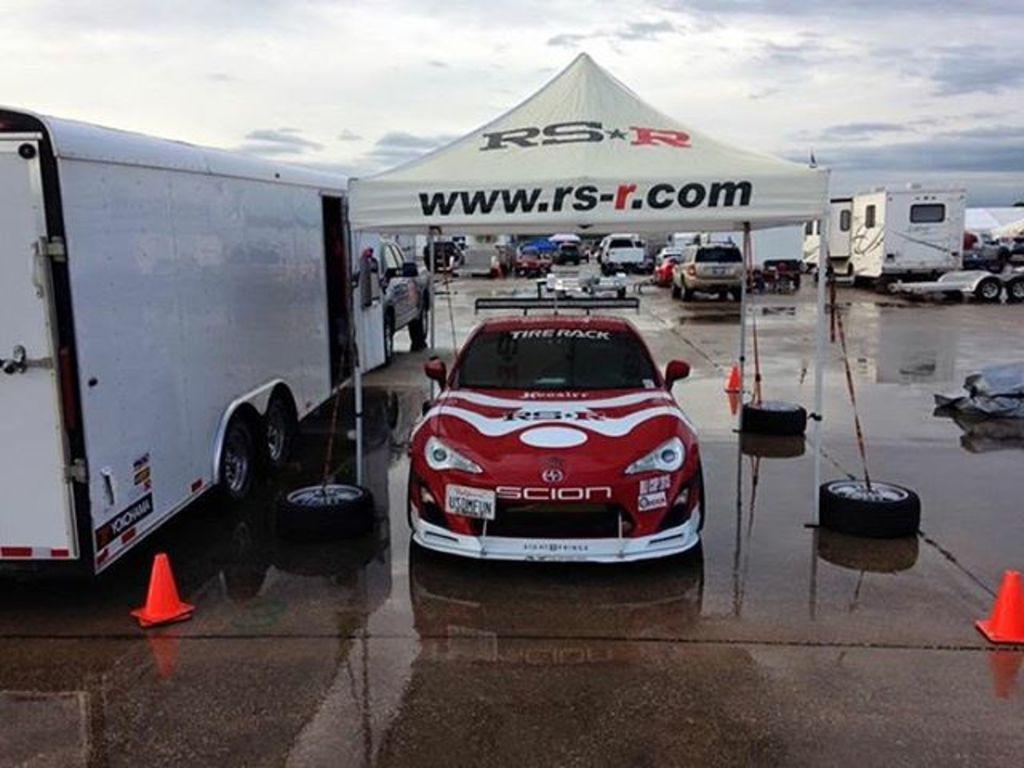What types of vehicles can be seen in the image? There are cars and other vehicles in the image. How are the vehicles positioned in the image? The vehicles are parked. What additional structure is present in the image? There is a tent in the image. Which vehicle is under the tent? A car is under the tent. How would you describe the weather based on the sky in the image? The sky is blue and cloudy in the image, suggesting a partly cloudy day. How many drawers are visible in the image? There are no drawers present in the image. What type of trouble is the car under the tent experiencing? There is no indication of any trouble for the car in the image; it is simply parked under the tent. 